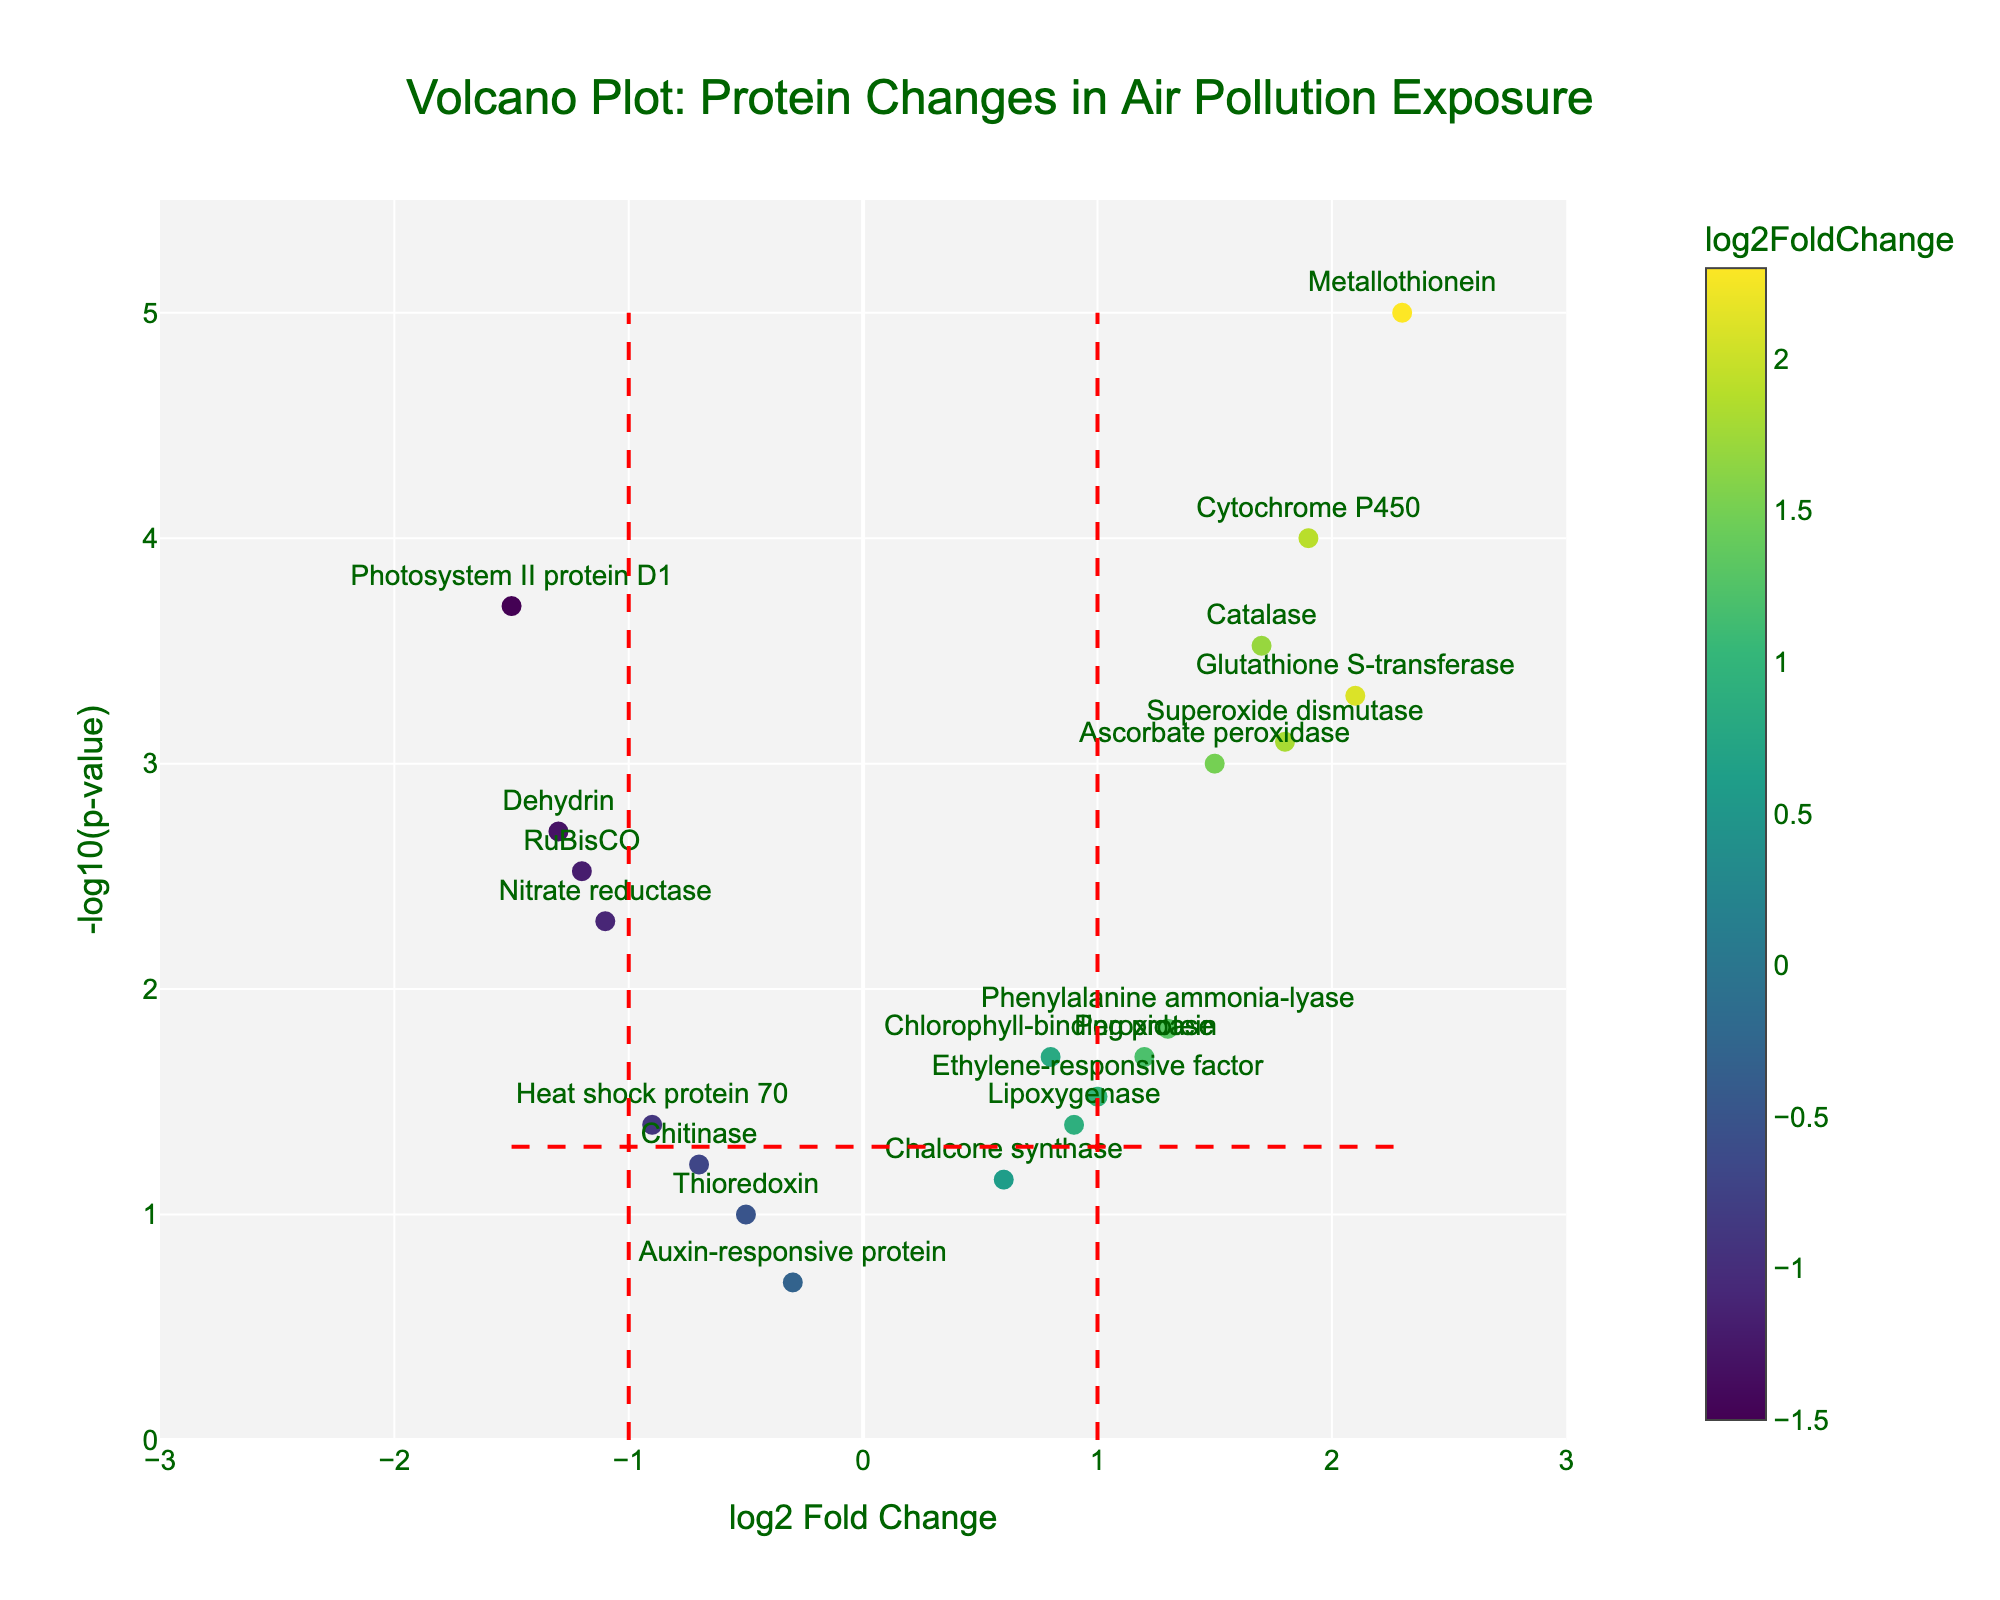1. What is the title of the plot? The title is located at the top center of the figure and reads "Volcano Plot: Protein Changes in Air Pollution Exposure".
Answer: Volcano Plot: Protein Changes in Air Pollution Exposure 2. What is the color of the points representing the proteins, and what does it indicate? The points are colored on a gradient scale from yellow to purple. This color represents the log2FoldChange, with values indicated on the color bar to the right of the plot.
Answer: The colors represent log2FoldChange 3. How many proteins have a negative log2FoldChange? To determine this, count the number of points that are to the left of the center vertical axis (log2FoldChange < 0). There are six such proteins: RuBisCO, Heat shock protein 70, Thioredoxin, Chalcone synthase, Chitinase, Dehydrin, and Nitrate reductase.
Answer: Six 4. Which protein has the highest -log10(p-value), and what is its corresponding log2FoldChange? The protein with the highest -log10(p-value) is Metallothionein, positioned at the topmost point on the plot. Its log2FoldChange is 2.3.
Answer: Metallothionein, 2.3 5. Which proteins are both statistically significant and show a higher abundance in polluted air conditions? Proteins that are statistically significant fall above the dashed horizontal line (-log10(p-value) = 1.3, corresponding to p-value = 0.05) and to the right of the vertical line at log2FoldChange = 1. They include Ascorbate peroxidase, Glutathione S-transferase, Superoxide dismutase, Catalase, Cytochrome P450, and Metallothionein.
Answer: Ascorbate peroxidase, Glutathione S-transferase, Superoxide dismutase, Catalase, Cytochrome P450, Metallothionein 6. What are the log2FoldChange and p-value of Nitrate reductase? Nitrate reductase is labeled on the plot and is found at log2FoldChange = -1.1 and -log10(p-value) ≈ 2.3, which converts to p-value = 0.005.
Answer: -1.1, 0.005 7. Of the proteins that are significantly less abundant in polluted conditions, which one shows the greatest decrease in abundance? Among the proteins with log2FoldChange < 0 and p-value < 0.05, Photosystem II protein D1 shows the greatest decrease with a log2FoldChange of -1.5.
Answer: Photosystem II protein D1 8. How many proteins have a log2FoldChange between -0.5 and 0.5, and are not statistically significant (p-value > 0.05)? Proteins with log2FoldChange between -0.5 and 0.5 and p-value > 0.05 are Ethylene-responsive factor, Auxin-responsive protein, Thioredoxin, and Chalcone synthase.
Answer: Four 9. What are the proteins with the highest and lowest log2FoldChange values, and what are their corresponding -log10(p-values)? The protein with the highest log2FoldChange (2.3) is Metallothionein, with -log10(p-value) ≈ 5. The protein with the lowest log2FoldChange (-1.5) is Photosystem II protein D1, with -log10(p-value) ≈ 3.7.
Answer: Metallothionein (5), Photosystem II protein D1 (3.7) 10. Which protein is closest to having a log2FoldChange of exactly 0, and what is its -log10(p-value)? The protein closest to log2FoldChange = 0 is Chalcone synthase with a log2FoldChange of 0.6 and a -log10(p-value) ≈ 1.15 (p-value = 0.07).
Answer: Chalcone synthase (1.15) 